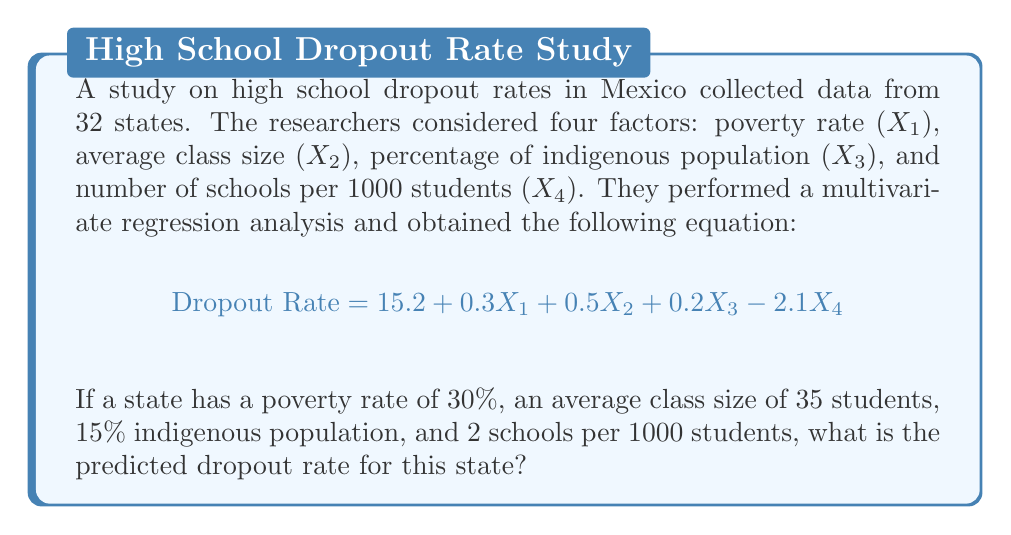Provide a solution to this math problem. Let's approach this step-by-step:

1) We have the regression equation:
   $$ \text{Dropout Rate} = 15.2 + 0.3X_1 + 0.5X_2 + 0.2X_3 - 2.1X_4 $$

2) We need to substitute the given values into this equation:
   - $X_1$ (poverty rate) = 30%
   - $X_2$ (average class size) = 35 students
   - $X_3$ (percentage of indigenous population) = 15%
   - $X_4$ (number of schools per 1000 students) = 2

3) Let's substitute these values:
   $$ \text{Dropout Rate} = 15.2 + 0.3(30) + 0.5(35) + 0.2(15) - 2.1(2) $$

4) Now, let's calculate each term:
   $$ \text{Dropout Rate} = 15.2 + 9 + 17.5 + 3 - 4.2 $$

5) Finally, we sum up all the terms:
   $$ \text{Dropout Rate} = 40.5 $$

Therefore, the predicted dropout rate for this state is 40.5%.
Answer: 40.5% 